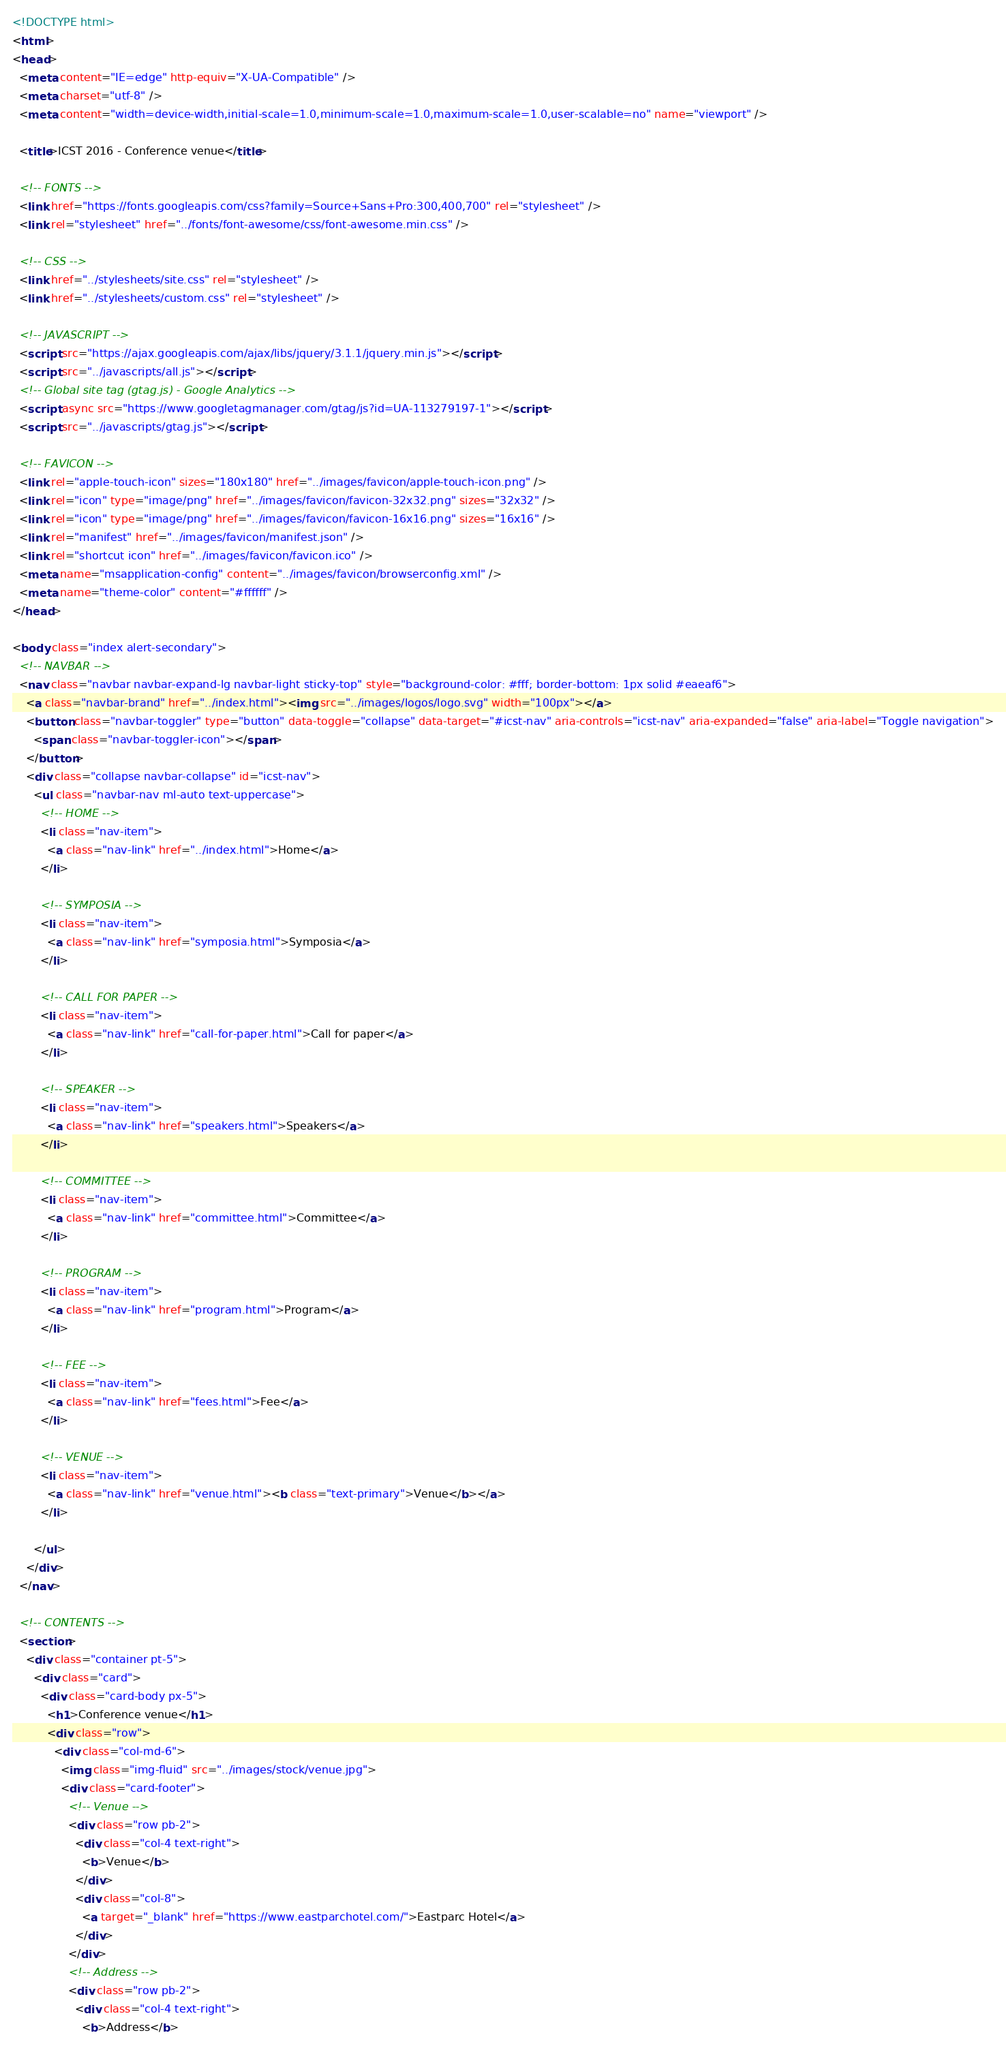<code> <loc_0><loc_0><loc_500><loc_500><_HTML_><!DOCTYPE html>
<html>
<head>
  <meta content="IE=edge" http-equiv="X-UA-Compatible" />
  <meta charset="utf-8" />
  <meta content="width=device-width,initial-scale=1.0,minimum-scale=1.0,maximum-scale=1.0,user-scalable=no" name="viewport" />
  
  <title>ICST 2016 - Conference venue</title>
  
  <!-- FONTS -->
  <link href="https://fonts.googleapis.com/css?family=Source+Sans+Pro:300,400,700" rel="stylesheet" />
  <link rel="stylesheet" href="../fonts/font-awesome/css/font-awesome.min.css" />
  
  <!-- CSS -->
  <link href="../stylesheets/site.css" rel="stylesheet" />
  <link href="../stylesheets/custom.css" rel="stylesheet" />
  
  <!-- JAVASCRIPT -->
  <script src="https://ajax.googleapis.com/ajax/libs/jquery/3.1.1/jquery.min.js"></script>
  <script src="../javascripts/all.js"></script>
  <!-- Global site tag (gtag.js) - Google Analytics -->
  <script async src="https://www.googletagmanager.com/gtag/js?id=UA-113279197-1"></script>
  <script src="../javascripts/gtag.js"></script>
  
  <!-- FAVICON -->
  <link rel="apple-touch-icon" sizes="180x180" href="../images/favicon/apple-touch-icon.png" />
  <link rel="icon" type="image/png" href="../images/favicon/favicon-32x32.png" sizes="32x32" />
  <link rel="icon" type="image/png" href="../images/favicon/favicon-16x16.png" sizes="16x16" />
  <link rel="manifest" href="../images/favicon/manifest.json" />
  <link rel="shortcut icon" href="../images/favicon/favicon.ico" />
  <meta name="msapplication-config" content="../images/favicon/browserconfig.xml" />
  <meta name="theme-color" content="#ffffff" />
</head>

<body class="index alert-secondary">
  <!-- NAVBAR -->
  <nav class="navbar navbar-expand-lg navbar-light sticky-top" style="background-color: #fff; border-bottom: 1px solid #eaeaf6">
    <a class="navbar-brand" href="../index.html"><img src="../images/logos/logo.svg" width="100px"></a>
    <button class="navbar-toggler" type="button" data-toggle="collapse" data-target="#icst-nav" aria-controls="icst-nav" aria-expanded="false" aria-label="Toggle navigation">
      <span class="navbar-toggler-icon"></span>
    </button>
    <div class="collapse navbar-collapse" id="icst-nav">
      <ul class="navbar-nav ml-auto text-uppercase">
        <!-- HOME -->
        <li class="nav-item">
          <a class="nav-link" href="../index.html">Home</a>
        </li>
        
        <!-- SYMPOSIA -->
        <li class="nav-item">
          <a class="nav-link" href="symposia.html">Symposia</a>
        </li>
        
        <!-- CALL FOR PAPER -->
        <li class="nav-item">
          <a class="nav-link" href="call-for-paper.html">Call for paper</a>
        </li>
        
        <!-- SPEAKER -->
        <li class="nav-item">
          <a class="nav-link" href="speakers.html">Speakers</a>
        </li>
        
        <!-- COMMITTEE -->
        <li class="nav-item">
          <a class="nav-link" href="committee.html">Committee</a>
        </li>
        
        <!-- PROGRAM -->
        <li class="nav-item">
          <a class="nav-link" href="program.html">Program</a>
        </li>
        
        <!-- FEE -->
        <li class="nav-item">
          <a class="nav-link" href="fees.html">Fee</a>
        </li>
        
        <!-- VENUE -->
        <li class="nav-item">
          <a class="nav-link" href="venue.html"><b class="text-primary">Venue</b></a>
        </li>
        
      </ul>
    </div>
  </nav>
  
  <!-- CONTENTS -->
  <section>
    <div class="container pt-5">
      <div class="card">
        <div class="card-body px-5">
          <h1>Conference venue</h1>
          <div class="row">
            <div class="col-md-6">
              <img class="img-fluid" src="../images/stock/venue.jpg">
              <div class="card-footer">
                <!-- Venue -->
                <div class="row pb-2">
                  <div class="col-4 text-right">
                    <b>Venue</b>
                  </div>
                  <div class="col-8">
                    <a target="_blank" href="https://www.eastparchotel.com/">Eastparc Hotel</a>
                  </div>
                </div>
                <!-- Address -->
                <div class="row pb-2">
                  <div class="col-4 text-right">
                    <b>Address</b></code> 